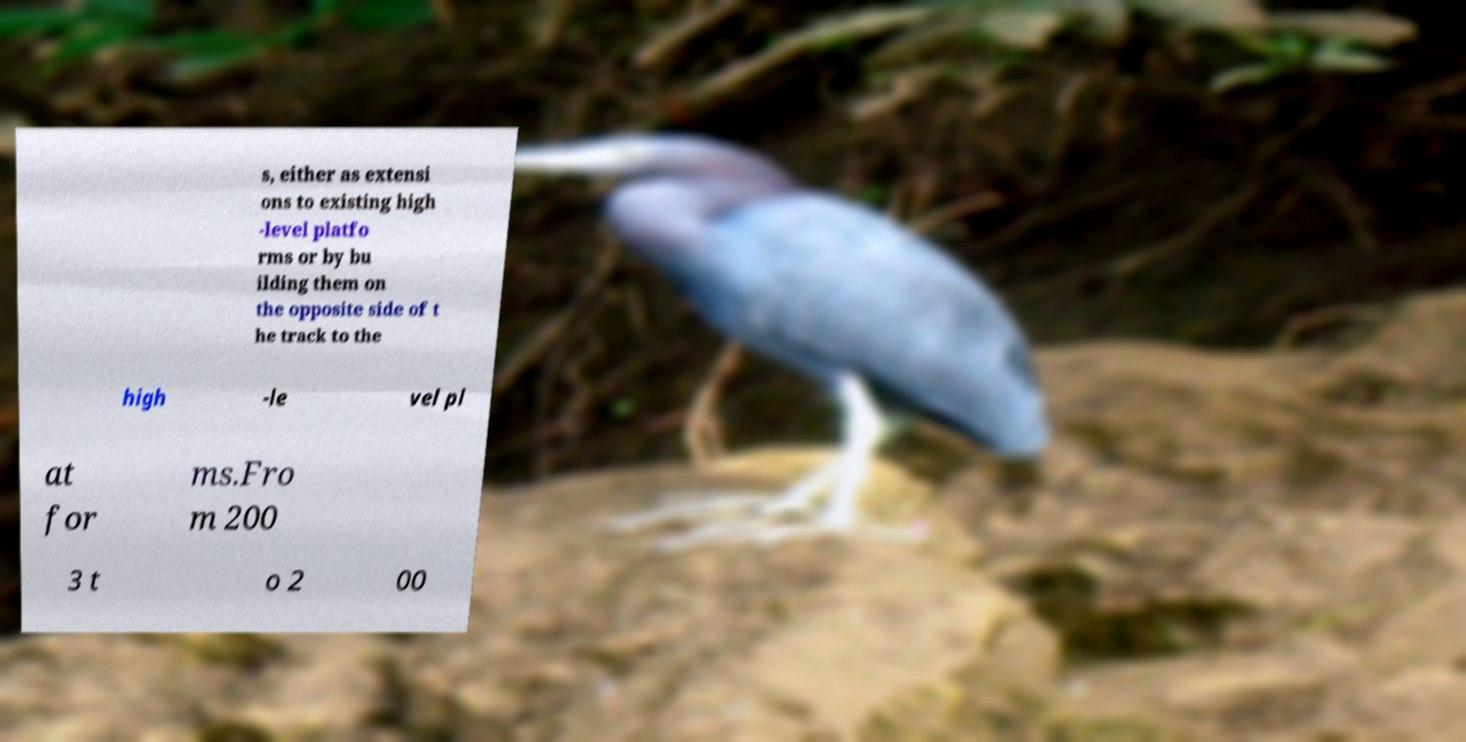Please read and relay the text visible in this image. What does it say? s, either as extensi ons to existing high -level platfo rms or by bu ilding them on the opposite side of t he track to the high -le vel pl at for ms.Fro m 200 3 t o 2 00 